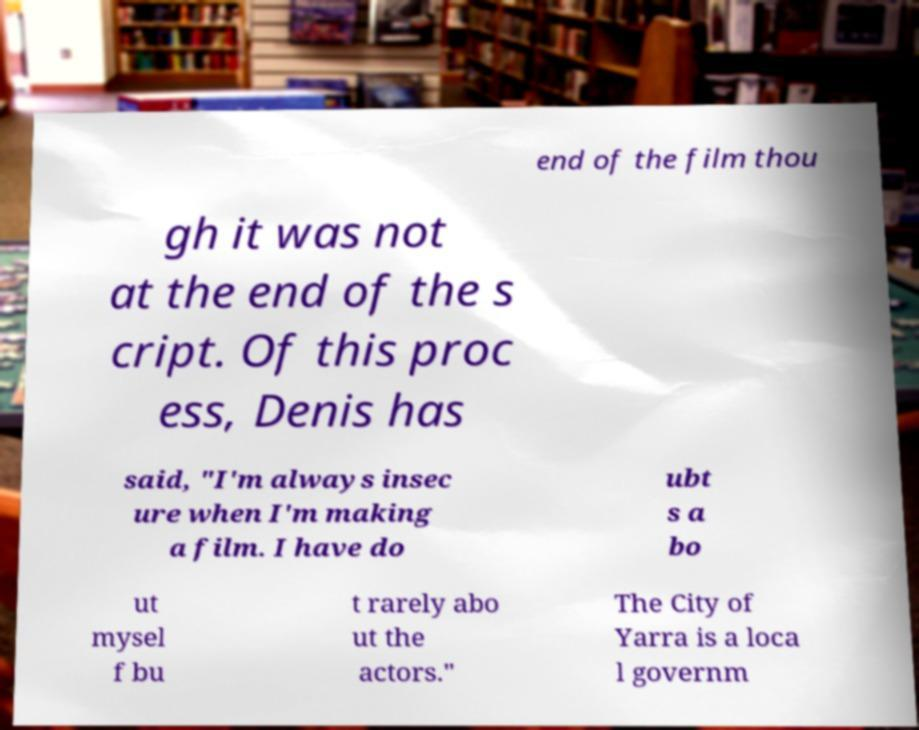What messages or text are displayed in this image? I need them in a readable, typed format. end of the film thou gh it was not at the end of the s cript. Of this proc ess, Denis has said, "I'm always insec ure when I'm making a film. I have do ubt s a bo ut mysel f bu t rarely abo ut the actors." The City of Yarra is a loca l governm 